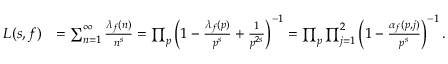<formula> <loc_0><loc_0><loc_500><loc_500>\begin{array} { r l } { L ( s , f ) } & { = \sum _ { n = 1 } ^ { \infty } \frac { \lambda _ { f } ( n ) } { n ^ { s } } = \prod _ { p } \left ( 1 - \frac { \lambda _ { f } ( p ) } { p ^ { s } } + \frac { 1 } { p ^ { 2 s } } \right ) ^ { - 1 } = \prod _ { p } \prod _ { j = 1 } ^ { 2 } \left ( 1 - \frac { \alpha _ { f } ( p , j ) } { p ^ { s } } \right ) ^ { - 1 } . } \end{array}</formula> 